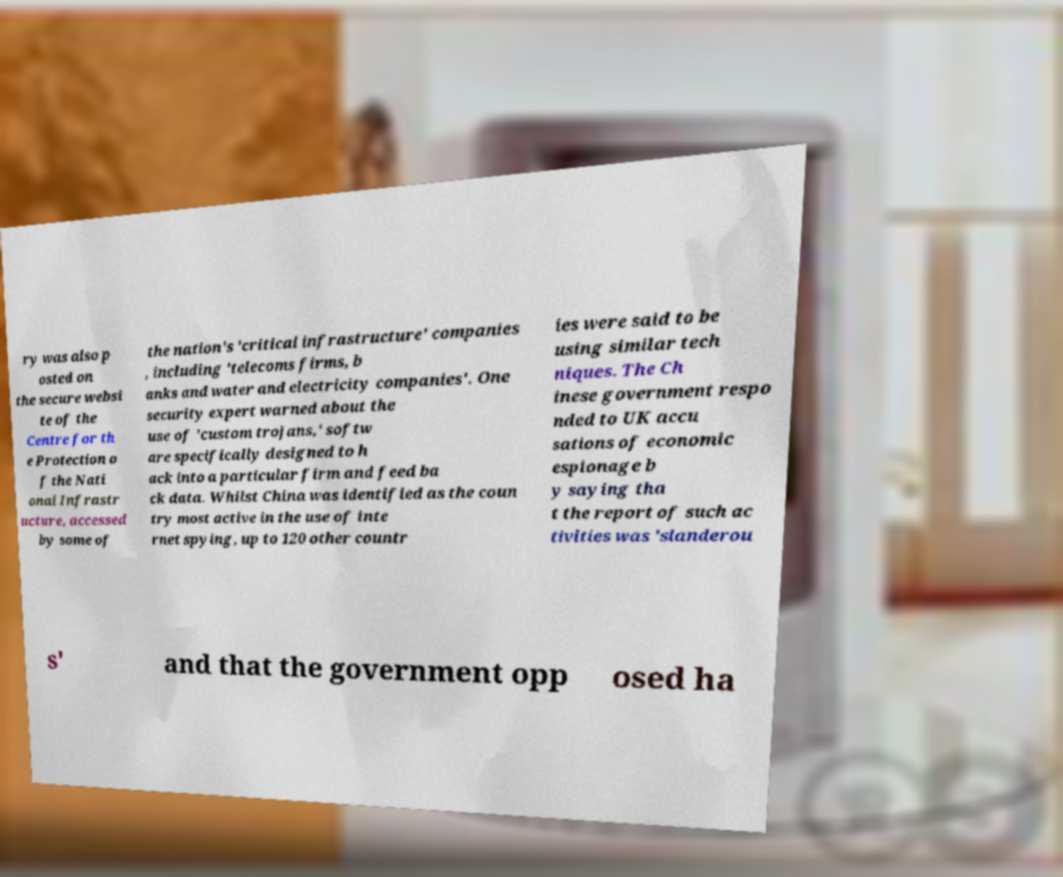I need the written content from this picture converted into text. Can you do that? ry was also p osted on the secure websi te of the Centre for th e Protection o f the Nati onal Infrastr ucture, accessed by some of the nation's 'critical infrastructure' companies , including 'telecoms firms, b anks and water and electricity companies'. One security expert warned about the use of 'custom trojans,' softw are specifically designed to h ack into a particular firm and feed ba ck data. Whilst China was identified as the coun try most active in the use of inte rnet spying, up to 120 other countr ies were said to be using similar tech niques. The Ch inese government respo nded to UK accu sations of economic espionage b y saying tha t the report of such ac tivities was 'slanderou s' and that the government opp osed ha 